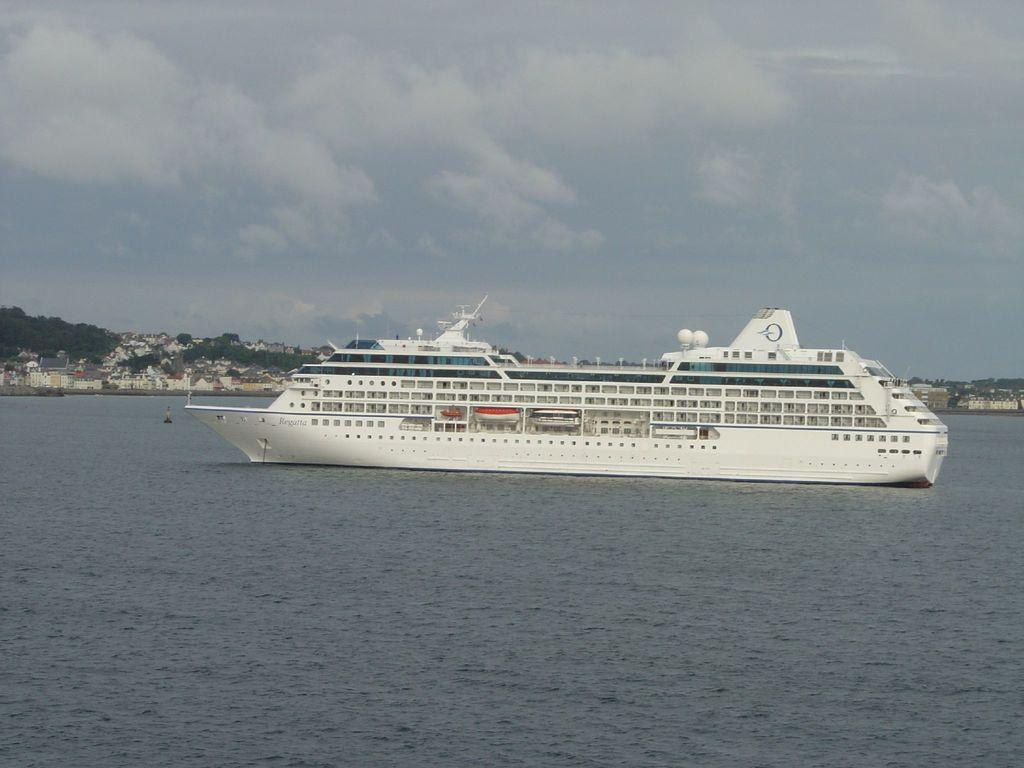What is the main subject in the foreground of the image? There is a ship in the foreground of the image. What is the ship's location in relation to the water? The ship is on the water. What can be seen in the background of the image? There are buildings, trees, and the sky visible in the background of the image. What is the condition of the sky in the image? The sky is visible in the background of the image, and there are clouds present. What type of bean is being used as a prop in the image? There is no bean present in the image; it features a ship on the water with buildings, trees, and clouds in the background. 